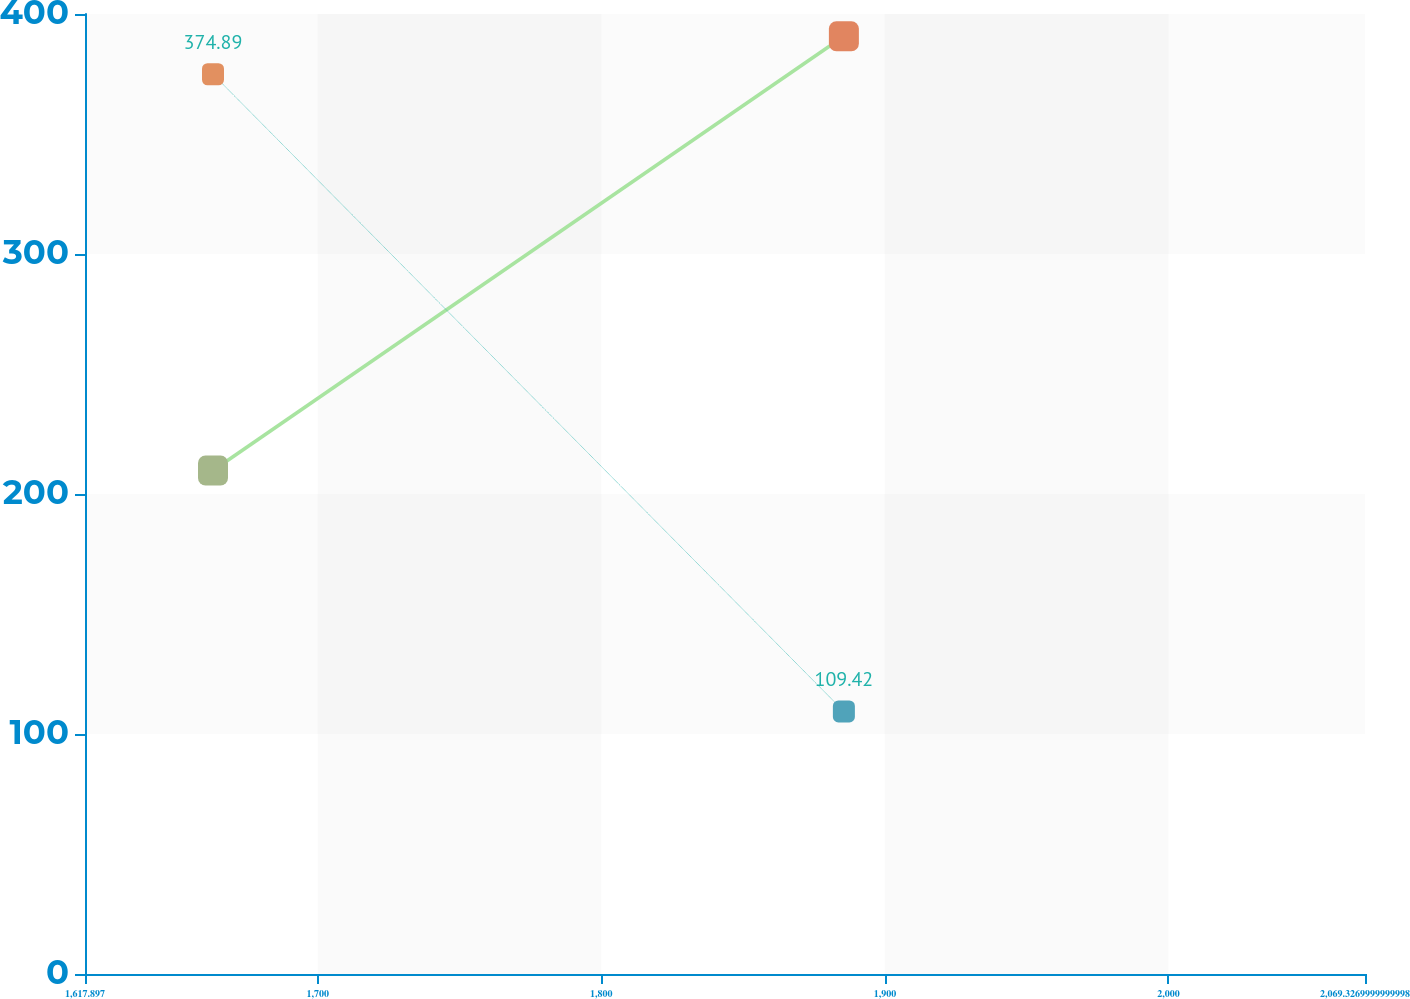Convert chart. <chart><loc_0><loc_0><loc_500><loc_500><line_chart><ecel><fcel>Interest Paid<fcel>Income Tax Refunds / (Payments)<nl><fcel>1663.04<fcel>209.8<fcel>374.89<nl><fcel>1885.54<fcel>390.72<fcel>109.42<nl><fcel>2114.47<fcel>474.1<fcel>402.37<nl></chart> 